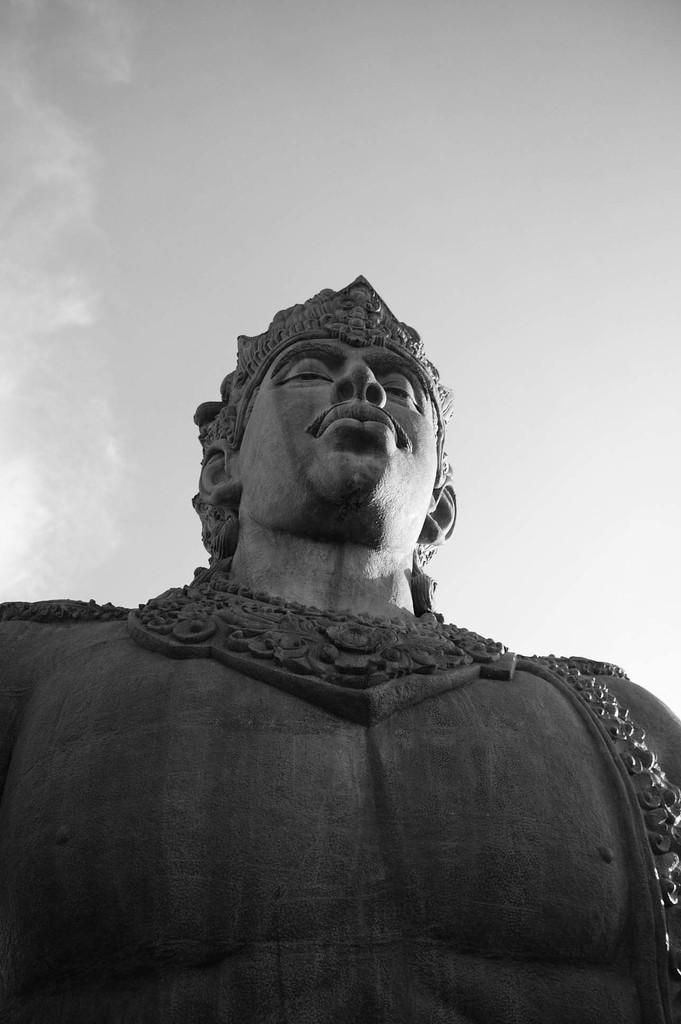How would you summarize this image in a sentence or two? In the center of the image we can see one statue, which is in black color. In the background we can see the sky and clouds. 